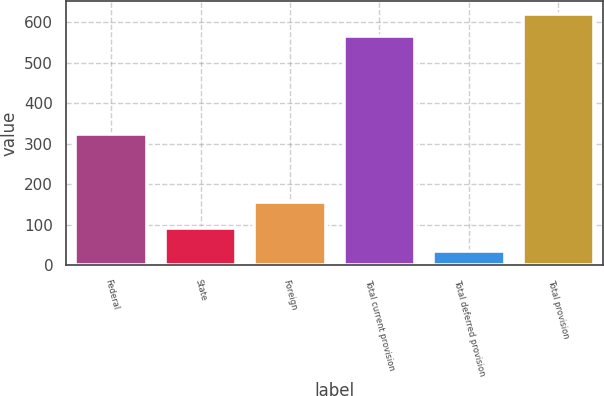<chart> <loc_0><loc_0><loc_500><loc_500><bar_chart><fcel>Federal<fcel>State<fcel>Foreign<fcel>Total current provision<fcel>Total deferred provision<fcel>Total provision<nl><fcel>325<fcel>90.5<fcel>155<fcel>565<fcel>34<fcel>621.5<nl></chart> 